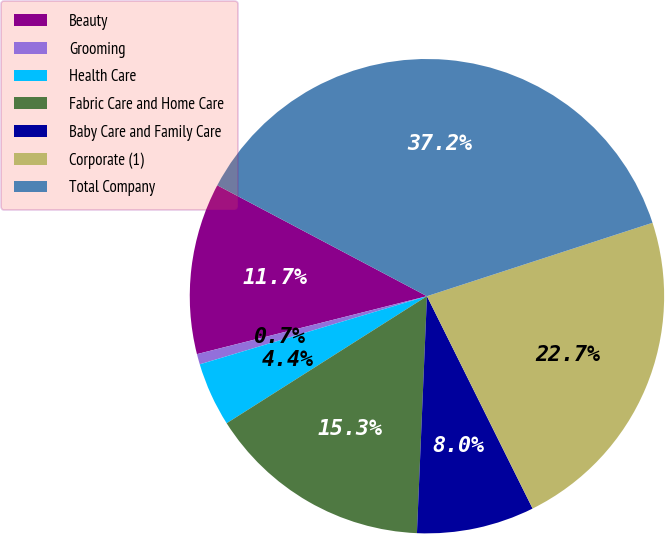Convert chart. <chart><loc_0><loc_0><loc_500><loc_500><pie_chart><fcel>Beauty<fcel>Grooming<fcel>Health Care<fcel>Fabric Care and Home Care<fcel>Baby Care and Family Care<fcel>Corporate (1)<fcel>Total Company<nl><fcel>11.67%<fcel>0.71%<fcel>4.36%<fcel>15.33%<fcel>8.02%<fcel>22.66%<fcel>37.25%<nl></chart> 